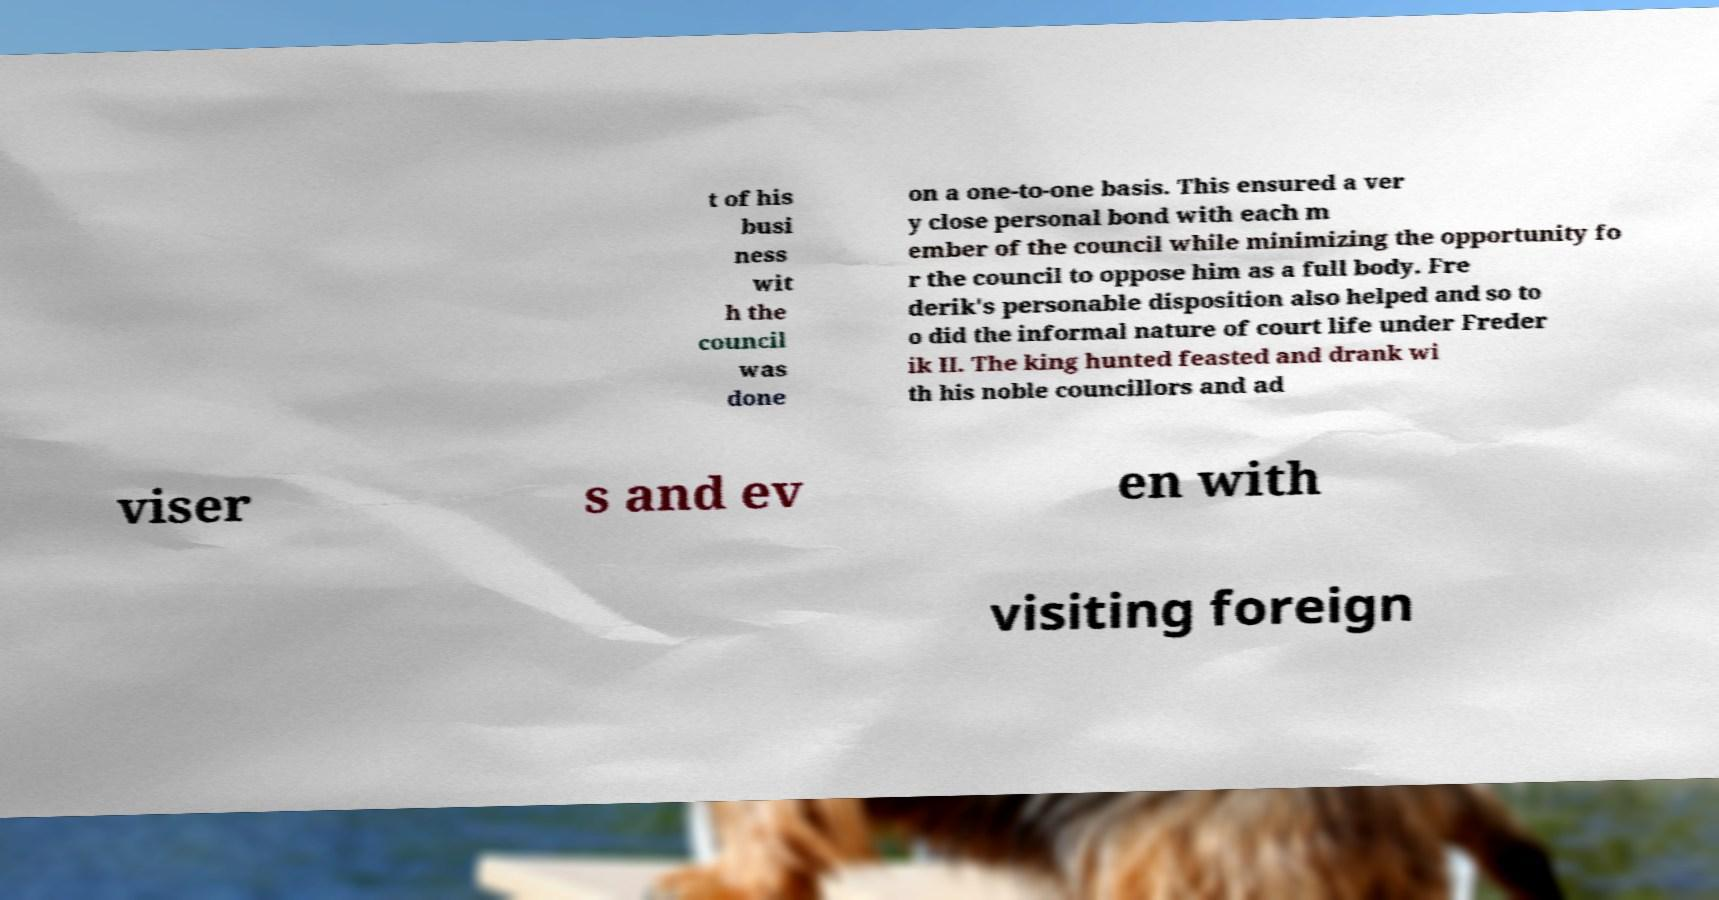For documentation purposes, I need the text within this image transcribed. Could you provide that? t of his busi ness wit h the council was done on a one-to-one basis. This ensured a ver y close personal bond with each m ember of the council while minimizing the opportunity fo r the council to oppose him as a full body. Fre derik's personable disposition also helped and so to o did the informal nature of court life under Freder ik II. The king hunted feasted and drank wi th his noble councillors and ad viser s and ev en with visiting foreign 